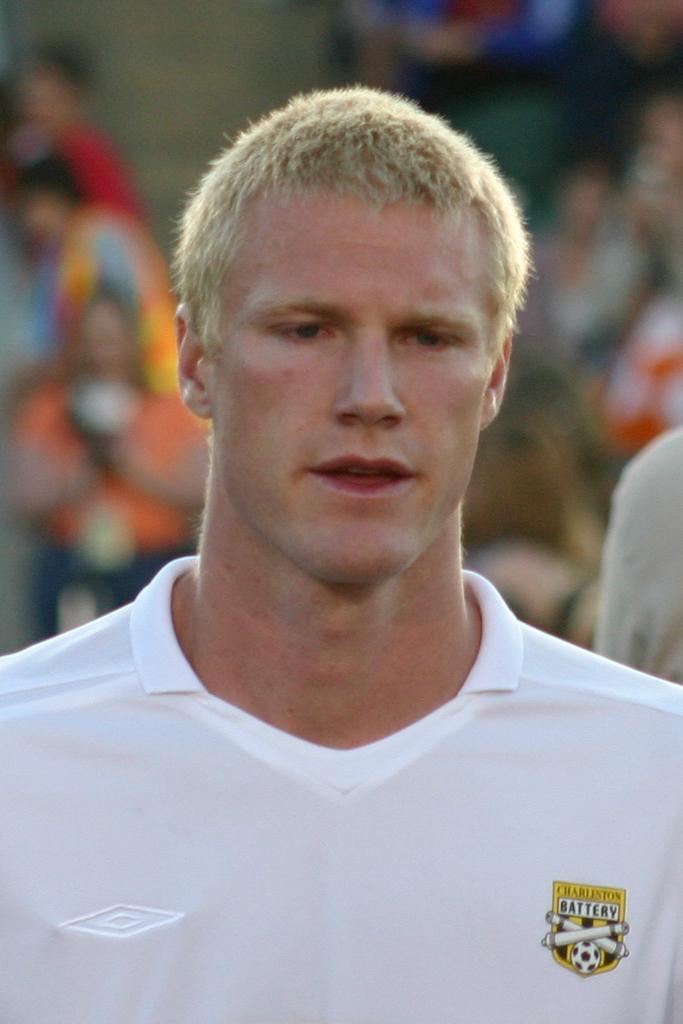In one or two sentences, can you explain what this image depicts? In this image I can see a person wearing a white t shirt and the background is blurred. 